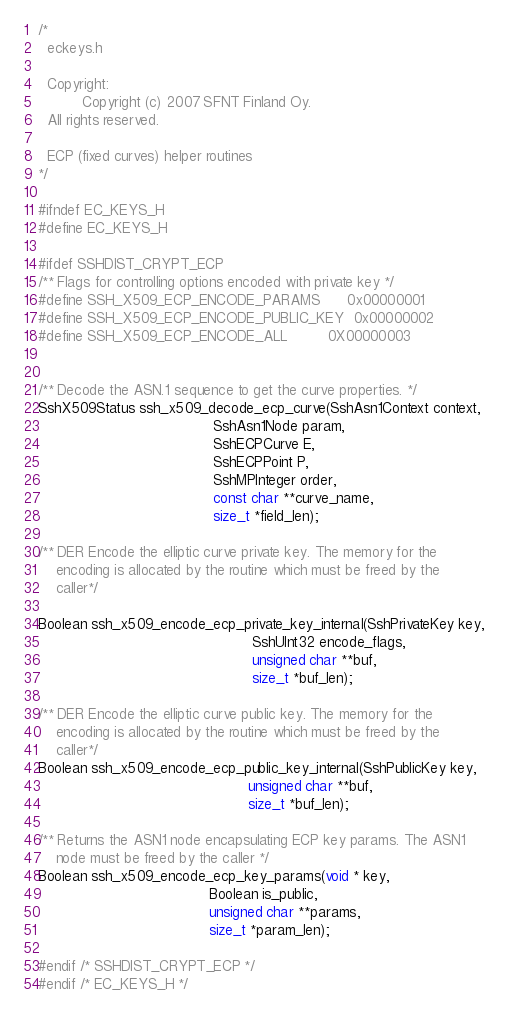Convert code to text. <code><loc_0><loc_0><loc_500><loc_500><_C_>/* 
  eckeys.h

  Copyright:
          Copyright (c) 2007 SFNT Finland Oy.
  All rights reserved.

  ECP (fixed curves) helper routines 
*/

#ifndef EC_KEYS_H
#define EC_KEYS_H

#ifdef SSHDIST_CRYPT_ECP
/** Flags for controlling options encoded with private key */
#define SSH_X509_ECP_ENCODE_PARAMS      0x00000001
#define SSH_X509_ECP_ENCODE_PUBLIC_KEY  0x00000002
#define SSH_X509_ECP_ENCODE_ALL         0X00000003


/** Decode the ASN.1 sequence to get the curve properties. */
SshX509Status ssh_x509_decode_ecp_curve(SshAsn1Context context,
                                        SshAsn1Node param,
                                        SshECPCurve E,
                                        SshECPPoint P,
                                        SshMPInteger order,
                                        const char **curve_name,
                                        size_t *field_len);

/** DER Encode the elliptic curve private key. The memory for the 
    encoding is allocated by the routine which must be freed by the 
    caller*/

Boolean ssh_x509_encode_ecp_private_key_internal(SshPrivateKey key,
                                                 SshUInt32 encode_flags,
                                                 unsigned char **buf,
                                                 size_t *buf_len);

/** DER Encode the elliptic curve public key. The memory for the 
    encoding is allocated by the routine which must be freed by the 
    caller*/
Boolean ssh_x509_encode_ecp_public_key_internal(SshPublicKey key,
                                                unsigned char **buf,
                                                size_t *buf_len);

/** Returns the ASN1 node encapsulating ECP key params. The ASN1
    node must be freed by the caller */
Boolean ssh_x509_encode_ecp_key_params(void * key,
                                       Boolean is_public,
                                       unsigned char **params,
                                       size_t *param_len);

#endif /* SSHDIST_CRYPT_ECP */
#endif /* EC_KEYS_H */
</code> 